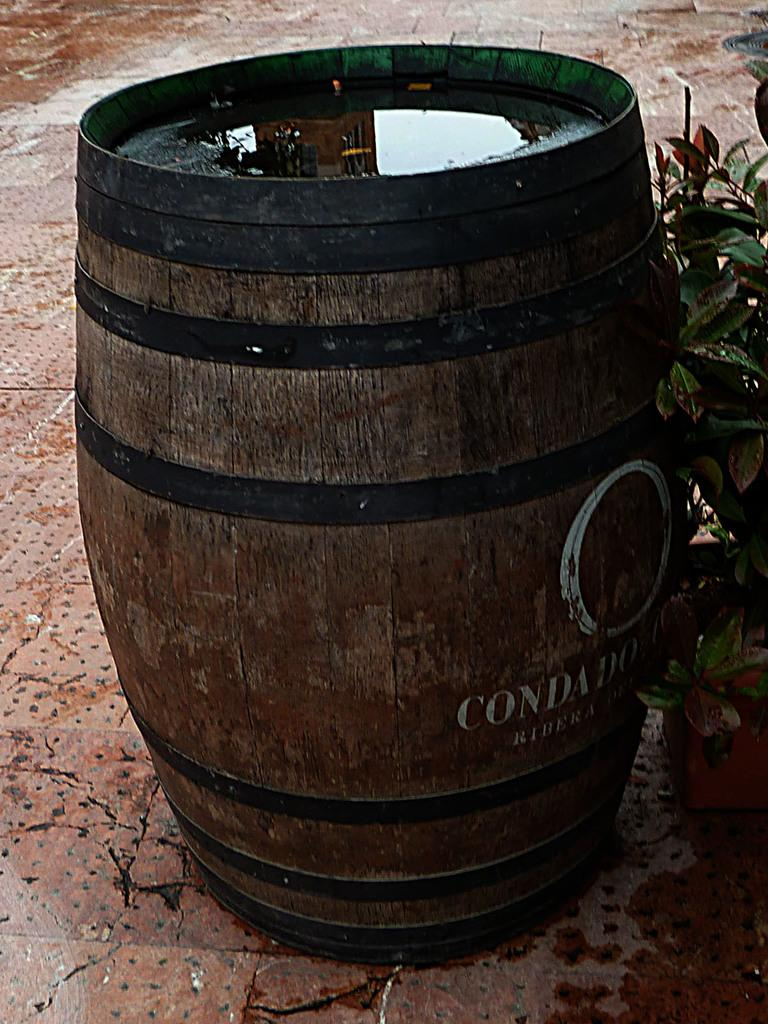<image>
Describe the image concisely. A large wood barrel with text on the front that begins with the letter "C". 